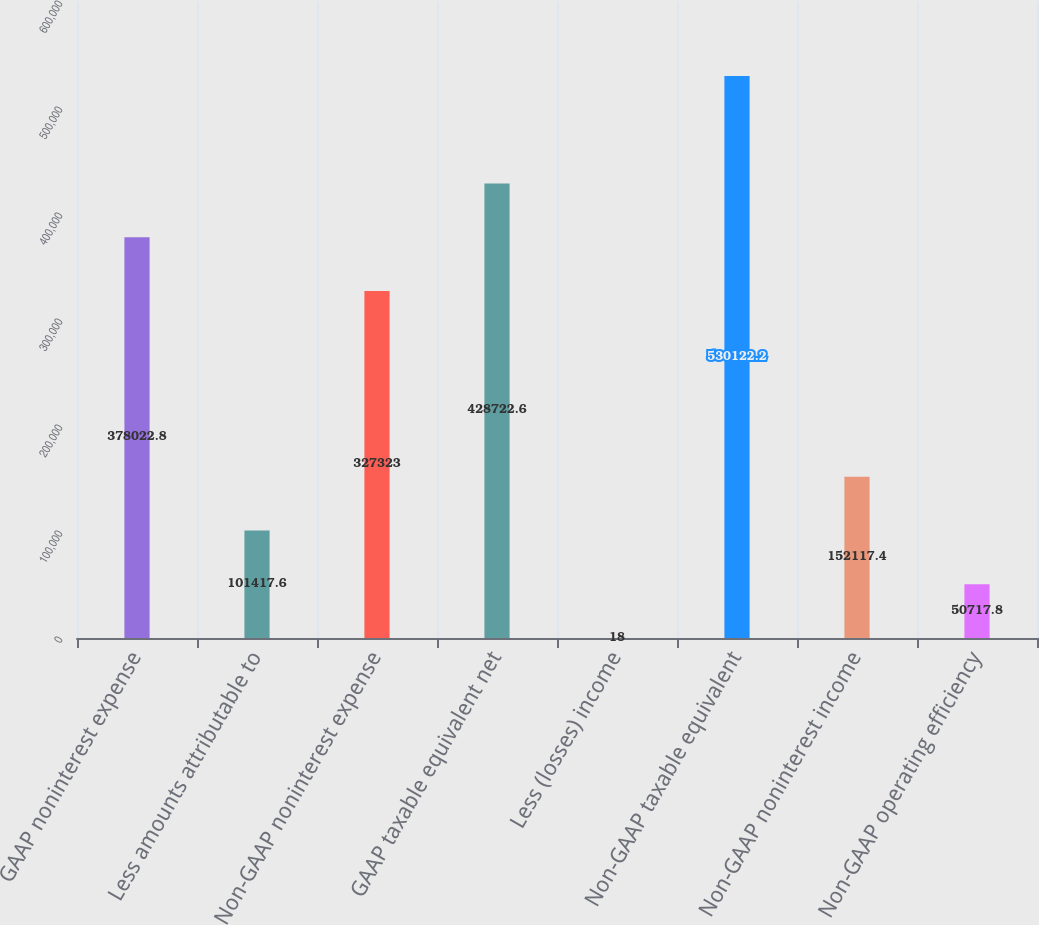Convert chart. <chart><loc_0><loc_0><loc_500><loc_500><bar_chart><fcel>GAAP noninterest expense<fcel>Less amounts attributable to<fcel>Non-GAAP noninterest expense<fcel>GAAP taxable equivalent net<fcel>Less (losses) income<fcel>Non-GAAP taxable equivalent<fcel>Non-GAAP noninterest income<fcel>Non-GAAP operating efficiency<nl><fcel>378023<fcel>101418<fcel>327323<fcel>428723<fcel>18<fcel>530122<fcel>152117<fcel>50717.8<nl></chart> 